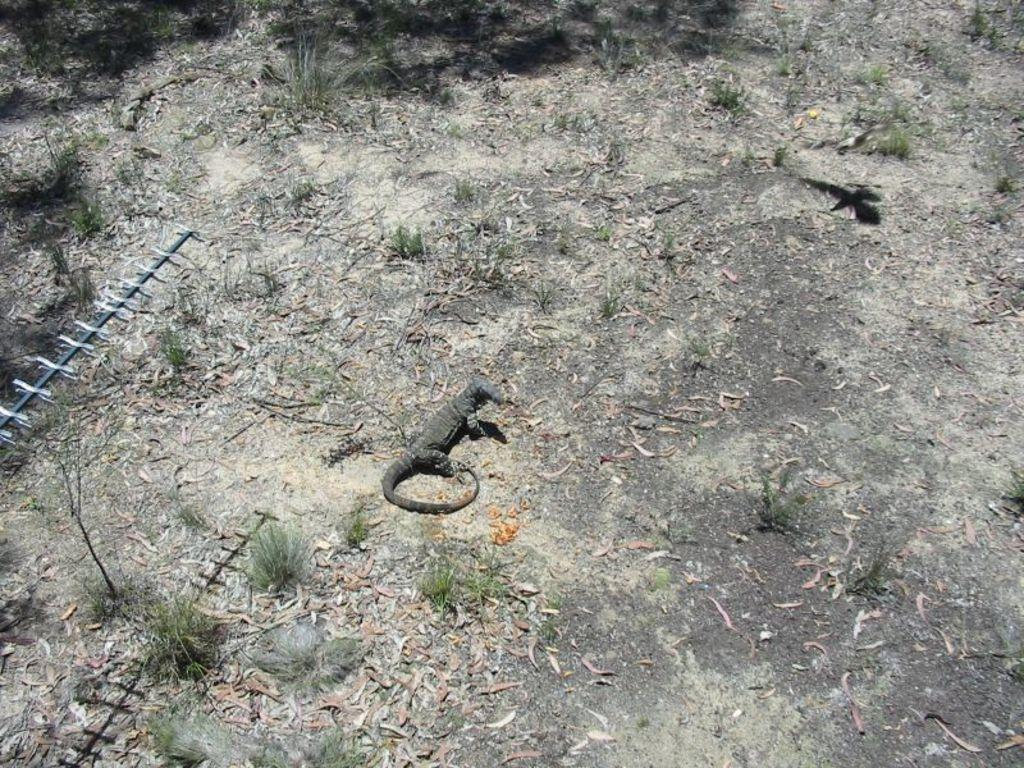What type of surface is visible in the image? There is ground visible in the image. What animal can be seen on the ground? There is a crocodile on the ground. What type of vegetation is present in the image? There is grass in the image. What color is the green object in the image? The green object in the image is not described, so we cannot determine its color. What can be seen in the image that indicates the presence of light? There is a shadow in the image, which suggests the presence of light. Can you tell me how many chess pieces are on the seashore in the image? There is no mention of chess pieces or a seashore in the image; it features a crocodile on the ground with grass and a shadow. 